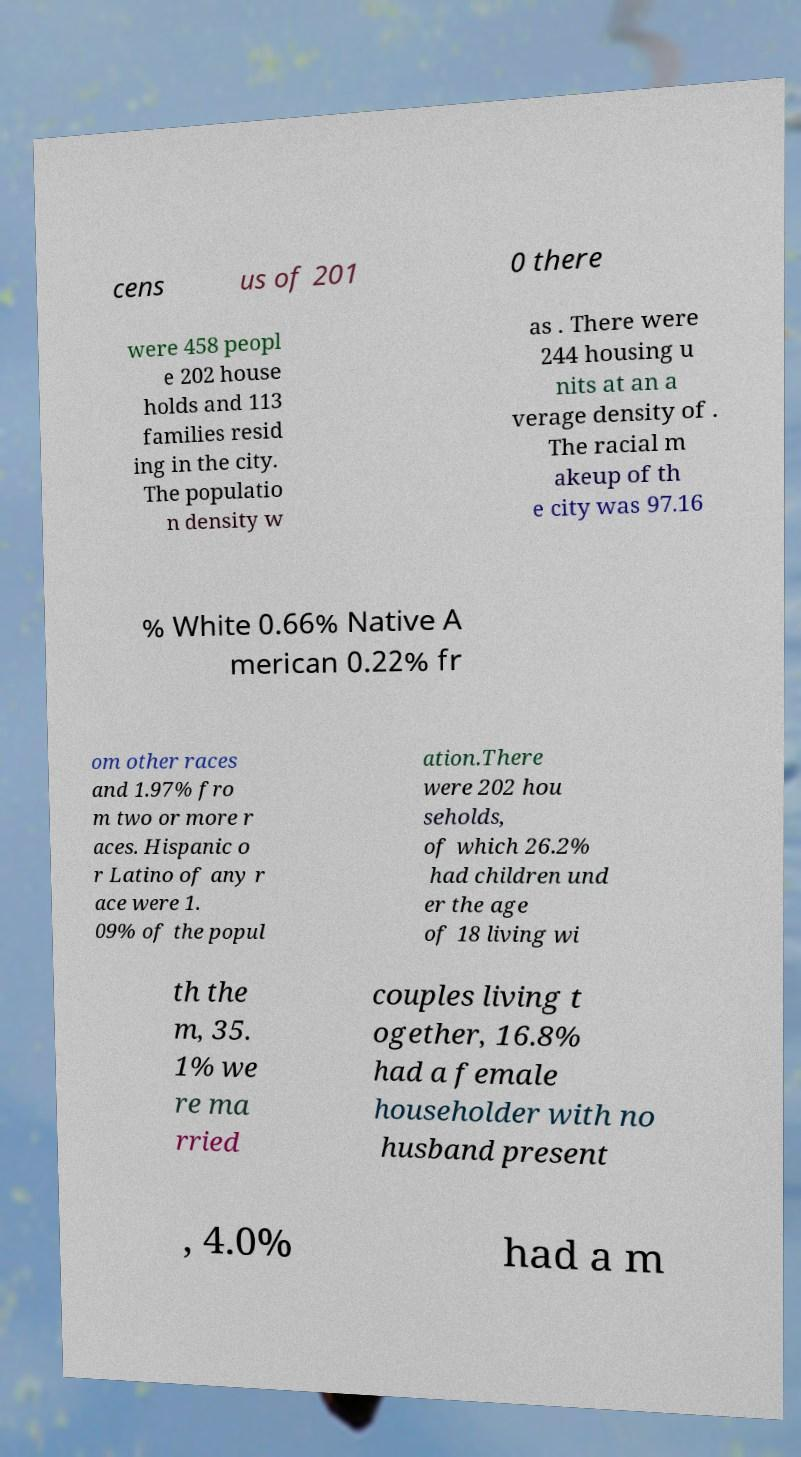What messages or text are displayed in this image? I need them in a readable, typed format. cens us of 201 0 there were 458 peopl e 202 house holds and 113 families resid ing in the city. The populatio n density w as . There were 244 housing u nits at an a verage density of . The racial m akeup of th e city was 97.16 % White 0.66% Native A merican 0.22% fr om other races and 1.97% fro m two or more r aces. Hispanic o r Latino of any r ace were 1. 09% of the popul ation.There were 202 hou seholds, of which 26.2% had children und er the age of 18 living wi th the m, 35. 1% we re ma rried couples living t ogether, 16.8% had a female householder with no husband present , 4.0% had a m 